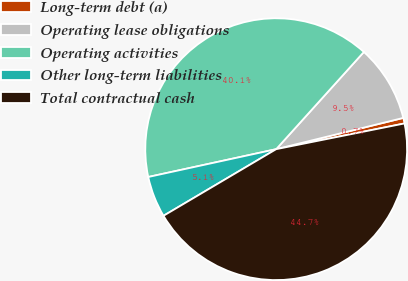<chart> <loc_0><loc_0><loc_500><loc_500><pie_chart><fcel>Long-term debt (a)<fcel>Operating lease obligations<fcel>Operating activities<fcel>Other long-term liabilities<fcel>Total contractual cash<nl><fcel>0.69%<fcel>9.48%<fcel>40.09%<fcel>5.09%<fcel>44.65%<nl></chart> 